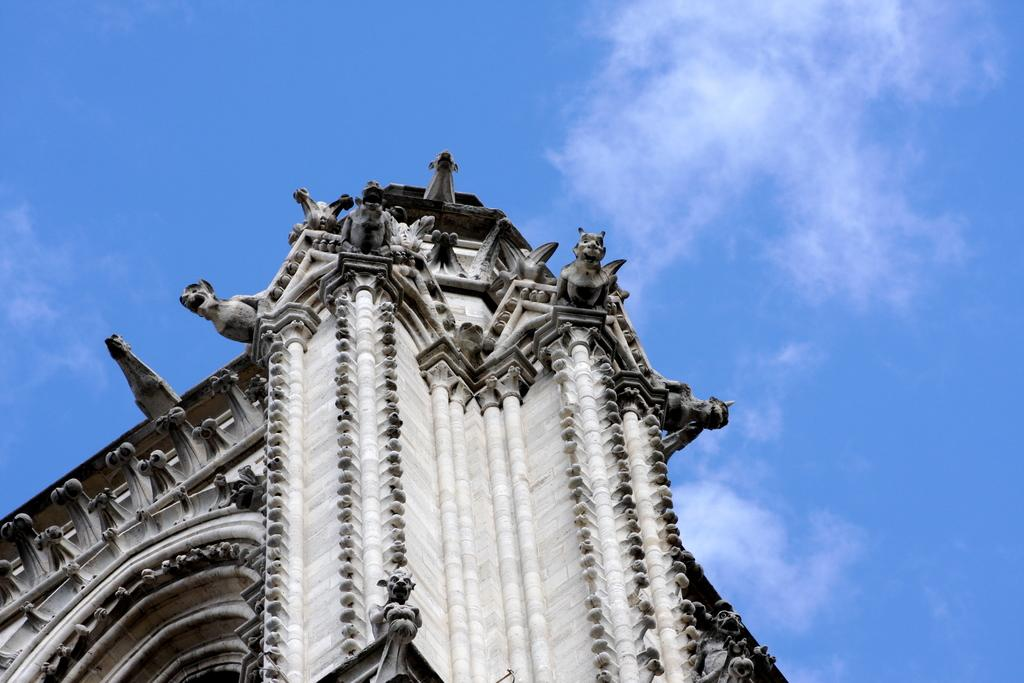What is the main subject of the image? There is a monument in the image. What can be seen on the monument? The monument has statues of animals. How would you describe the sky in the image? The sky is cloudy. What type of zipper can be seen on the monument in the image? There is no zipper present on the monument in the image. How does the room affect the monument in the image? There is no room mentioned in the image, so it cannot affect the monument. 